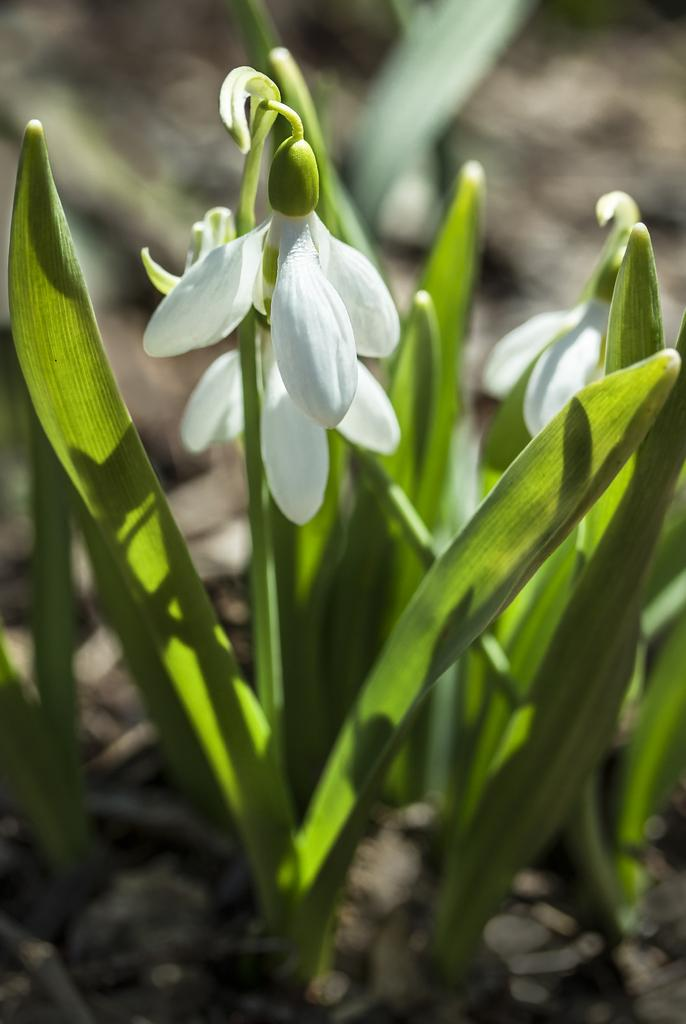What celestial bodies are visible in the image? There are planets visible in the image. What type of flora is present in the image? There are white color flowers in the image. What type of knowledge can be gained from the plate in the image? There is no plate present in the image, and therefore no such knowledge can be gained. 